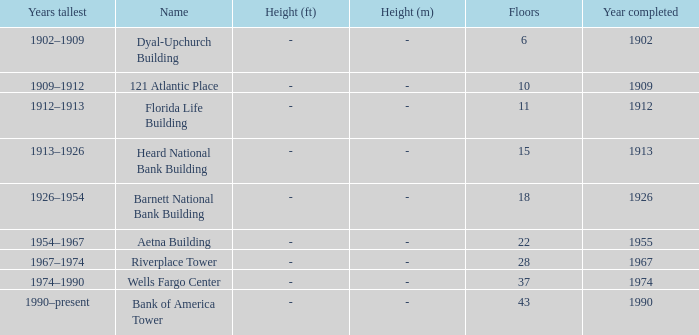In which year was the 10-story building finished? 1909.0. 